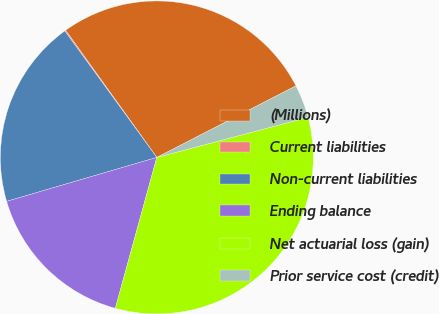<chart> <loc_0><loc_0><loc_500><loc_500><pie_chart><fcel>(Millions)<fcel>Current liabilities<fcel>Non-current liabilities<fcel>Ending balance<fcel>Net actuarial loss (gain)<fcel>Prior service cost (credit)<nl><fcel>27.34%<fcel>0.11%<fcel>19.52%<fcel>16.2%<fcel>33.4%<fcel>3.44%<nl></chart> 